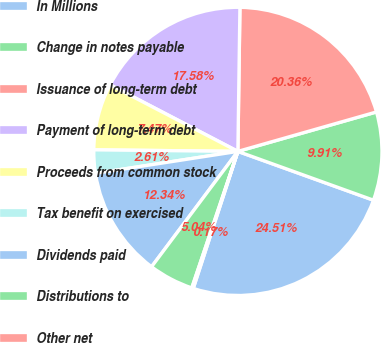Convert chart. <chart><loc_0><loc_0><loc_500><loc_500><pie_chart><fcel>In Millions<fcel>Change in notes payable<fcel>Issuance of long-term debt<fcel>Payment of long-term debt<fcel>Proceeds from common stock<fcel>Tax benefit on exercised<fcel>Dividends paid<fcel>Distributions to<fcel>Other net<nl><fcel>24.51%<fcel>9.91%<fcel>20.36%<fcel>17.58%<fcel>7.47%<fcel>2.61%<fcel>12.34%<fcel>5.04%<fcel>0.17%<nl></chart> 